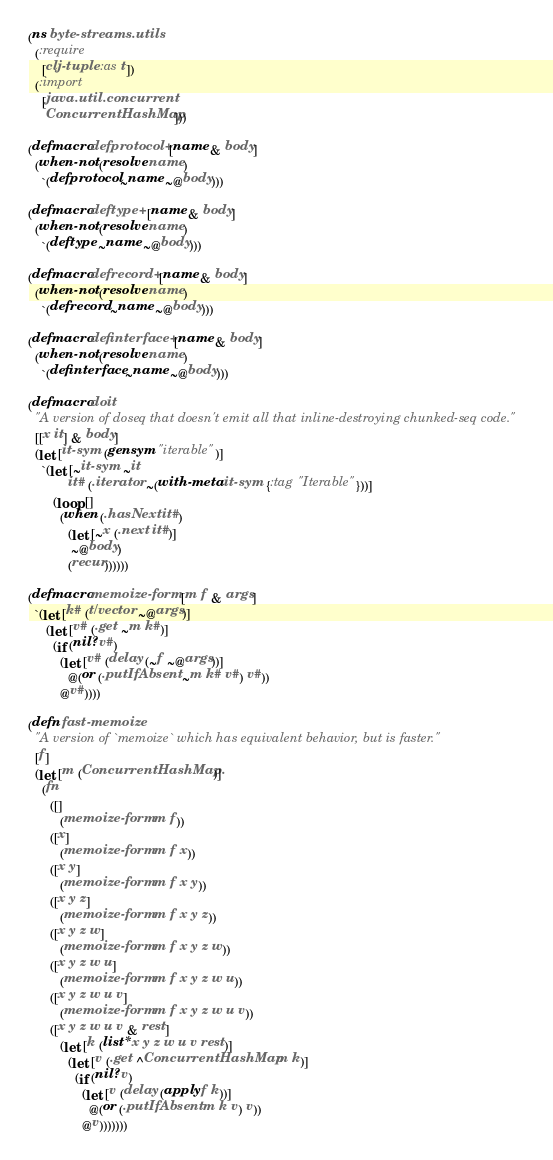Convert code to text. <code><loc_0><loc_0><loc_500><loc_500><_Clojure_>(ns byte-streams.utils
  (:require
    [clj-tuple :as t])
  (:import
    [java.util.concurrent
     ConcurrentHashMap]))

(defmacro defprotocol+ [name & body]
  (when-not (resolve name)
    `(defprotocol ~name ~@body)))

(defmacro deftype+ [name & body]
  (when-not (resolve name)
    `(deftype ~name ~@body)))

(defmacro defrecord+ [name & body]
  (when-not (resolve name)
    `(defrecord ~name ~@body)))

(defmacro definterface+ [name & body]
  (when-not (resolve name)
    `(definterface ~name ~@body)))

(defmacro doit
  "A version of doseq that doesn't emit all that inline-destroying chunked-seq code."
  [[x it] & body]
  (let [it-sym (gensym "iterable")]
    `(let [~it-sym ~it
           it# (.iterator ~(with-meta it-sym {:tag "Iterable"}))]
       (loop []
         (when (.hasNext it#)
           (let [~x (.next it#)]
            ~@body)
           (recur))))))

(defmacro memoize-form [m f & args]
  `(let [k# (t/vector ~@args)]
     (let [v# (.get ~m k#)]
       (if (nil? v#)
         (let [v# (delay (~f ~@args))]
           @(or (.putIfAbsent ~m k# v#) v#))
         @v#))))

(defn fast-memoize
  "A version of `memoize` which has equivalent behavior, but is faster."
  [f]
  (let [m (ConcurrentHashMap.)]
    (fn
      ([]
         (memoize-form m f))
      ([x]
         (memoize-form m f x))
      ([x y]
         (memoize-form m f x y))
      ([x y z]
         (memoize-form m f x y z))
      ([x y z w]
         (memoize-form m f x y z w))
      ([x y z w u]
         (memoize-form m f x y z w u))
      ([x y z w u v]
         (memoize-form m f x y z w u v))
      ([x y z w u v & rest]
         (let [k (list* x y z w u v rest)]
           (let [v (.get ^ConcurrentHashMap m k)]
             (if (nil? v)
               (let [v (delay (apply f k))]
                 @(or (.putIfAbsent m k v) v))
               @v)))))))
</code> 